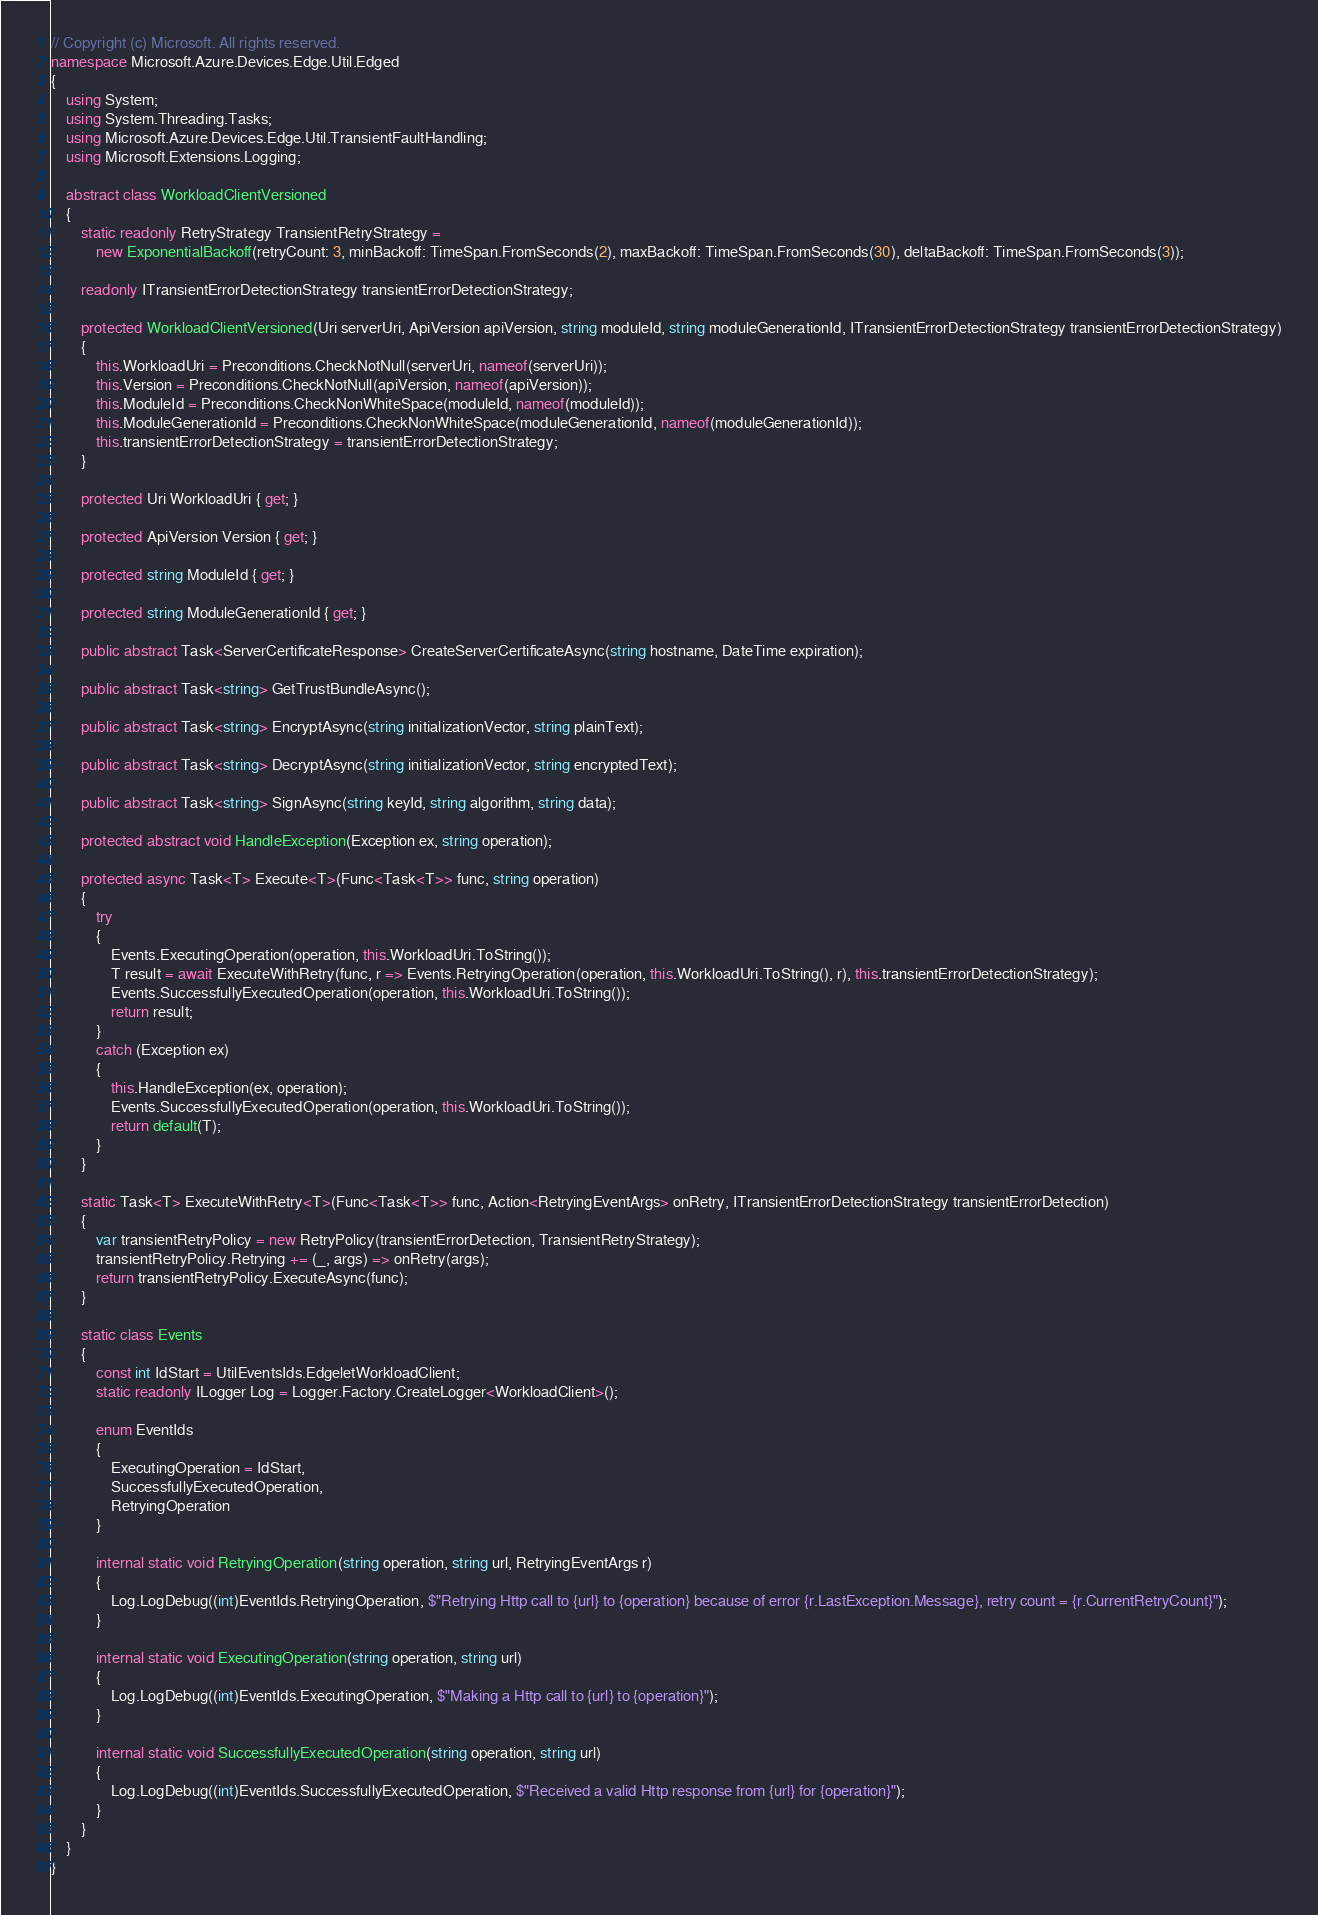Convert code to text. <code><loc_0><loc_0><loc_500><loc_500><_C#_>// Copyright (c) Microsoft. All rights reserved.
namespace Microsoft.Azure.Devices.Edge.Util.Edged
{
    using System;
    using System.Threading.Tasks;
    using Microsoft.Azure.Devices.Edge.Util.TransientFaultHandling;
    using Microsoft.Extensions.Logging;

    abstract class WorkloadClientVersioned
    {
        static readonly RetryStrategy TransientRetryStrategy =
            new ExponentialBackoff(retryCount: 3, minBackoff: TimeSpan.FromSeconds(2), maxBackoff: TimeSpan.FromSeconds(30), deltaBackoff: TimeSpan.FromSeconds(3));

        readonly ITransientErrorDetectionStrategy transientErrorDetectionStrategy;

        protected WorkloadClientVersioned(Uri serverUri, ApiVersion apiVersion, string moduleId, string moduleGenerationId, ITransientErrorDetectionStrategy transientErrorDetectionStrategy)
        {
            this.WorkloadUri = Preconditions.CheckNotNull(serverUri, nameof(serverUri));
            this.Version = Preconditions.CheckNotNull(apiVersion, nameof(apiVersion));
            this.ModuleId = Preconditions.CheckNonWhiteSpace(moduleId, nameof(moduleId));
            this.ModuleGenerationId = Preconditions.CheckNonWhiteSpace(moduleGenerationId, nameof(moduleGenerationId));
            this.transientErrorDetectionStrategy = transientErrorDetectionStrategy;
        }

        protected Uri WorkloadUri { get; }

        protected ApiVersion Version { get; }

        protected string ModuleId { get; }

        protected string ModuleGenerationId { get; }

        public abstract Task<ServerCertificateResponse> CreateServerCertificateAsync(string hostname, DateTime expiration);

        public abstract Task<string> GetTrustBundleAsync();

        public abstract Task<string> EncryptAsync(string initializationVector, string plainText);

        public abstract Task<string> DecryptAsync(string initializationVector, string encryptedText);

        public abstract Task<string> SignAsync(string keyId, string algorithm, string data);

        protected abstract void HandleException(Exception ex, string operation);

        protected async Task<T> Execute<T>(Func<Task<T>> func, string operation)
        {
            try
            {
                Events.ExecutingOperation(operation, this.WorkloadUri.ToString());
                T result = await ExecuteWithRetry(func, r => Events.RetryingOperation(operation, this.WorkloadUri.ToString(), r), this.transientErrorDetectionStrategy);
                Events.SuccessfullyExecutedOperation(operation, this.WorkloadUri.ToString());
                return result;
            }
            catch (Exception ex)
            {
                this.HandleException(ex, operation);
                Events.SuccessfullyExecutedOperation(operation, this.WorkloadUri.ToString());
                return default(T);
            }
        }

        static Task<T> ExecuteWithRetry<T>(Func<Task<T>> func, Action<RetryingEventArgs> onRetry, ITransientErrorDetectionStrategy transientErrorDetection)
        {
            var transientRetryPolicy = new RetryPolicy(transientErrorDetection, TransientRetryStrategy);
            transientRetryPolicy.Retrying += (_, args) => onRetry(args);
            return transientRetryPolicy.ExecuteAsync(func);
        }

        static class Events
        {
            const int IdStart = UtilEventsIds.EdgeletWorkloadClient;
            static readonly ILogger Log = Logger.Factory.CreateLogger<WorkloadClient>();

            enum EventIds
            {
                ExecutingOperation = IdStart,
                SuccessfullyExecutedOperation,
                RetryingOperation
            }

            internal static void RetryingOperation(string operation, string url, RetryingEventArgs r)
            {
                Log.LogDebug((int)EventIds.RetryingOperation, $"Retrying Http call to {url} to {operation} because of error {r.LastException.Message}, retry count = {r.CurrentRetryCount}");
            }

            internal static void ExecutingOperation(string operation, string url)
            {
                Log.LogDebug((int)EventIds.ExecutingOperation, $"Making a Http call to {url} to {operation}");
            }

            internal static void SuccessfullyExecutedOperation(string operation, string url)
            {
                Log.LogDebug((int)EventIds.SuccessfullyExecutedOperation, $"Received a valid Http response from {url} for {operation}");
            }
        }
    }
}
</code> 